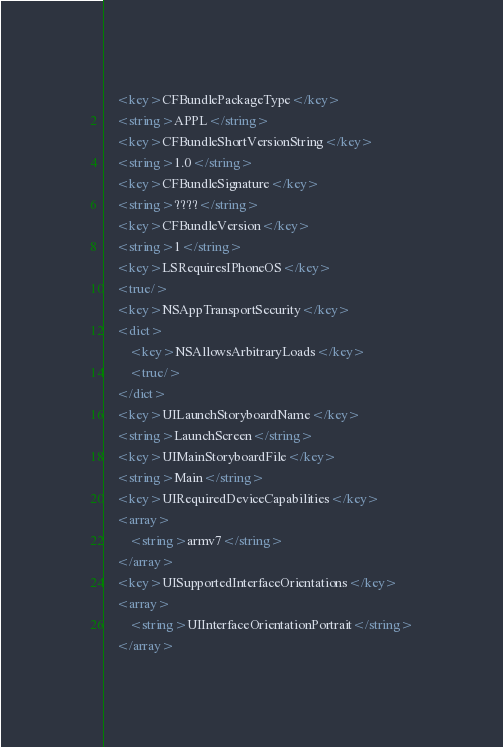<code> <loc_0><loc_0><loc_500><loc_500><_XML_>	<key>CFBundlePackageType</key>
	<string>APPL</string>
	<key>CFBundleShortVersionString</key>
	<string>1.0</string>
	<key>CFBundleSignature</key>
	<string>????</string>
	<key>CFBundleVersion</key>
	<string>1</string>
	<key>LSRequiresIPhoneOS</key>
	<true/>
	<key>NSAppTransportSecurity</key>
	<dict>
		<key>NSAllowsArbitraryLoads</key>
		<true/>
	</dict>
	<key>UILaunchStoryboardName</key>
	<string>LaunchScreen</string>
	<key>UIMainStoryboardFile</key>
	<string>Main</string>
	<key>UIRequiredDeviceCapabilities</key>
	<array>
		<string>armv7</string>
	</array>
	<key>UISupportedInterfaceOrientations</key>
	<array>
		<string>UIInterfaceOrientationPortrait</string>
	</array></code> 